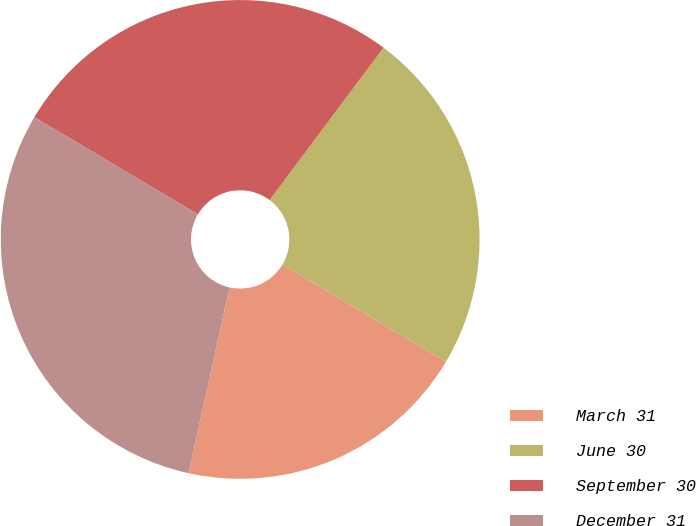Convert chart to OTSL. <chart><loc_0><loc_0><loc_500><loc_500><pie_chart><fcel>March 31<fcel>June 30<fcel>September 30<fcel>December 31<nl><fcel>19.93%<fcel>23.31%<fcel>26.69%<fcel>30.07%<nl></chart> 